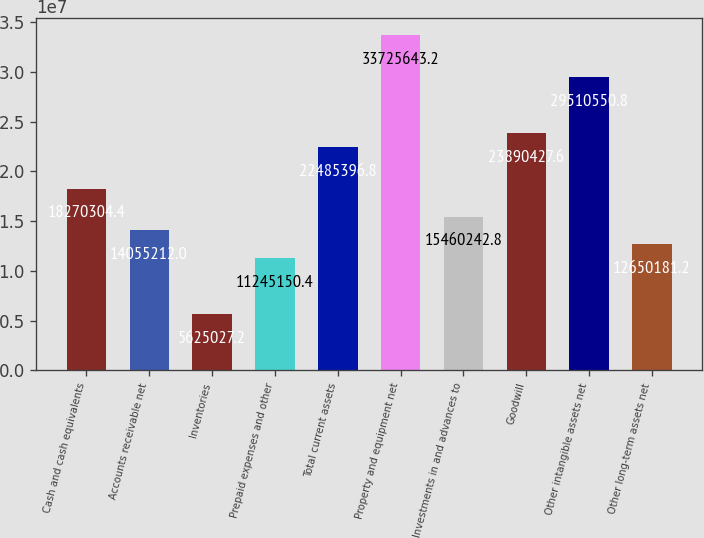<chart> <loc_0><loc_0><loc_500><loc_500><bar_chart><fcel>Cash and cash equivalents<fcel>Accounts receivable net<fcel>Inventories<fcel>Prepaid expenses and other<fcel>Total current assets<fcel>Property and equipment net<fcel>Investments in and advances to<fcel>Goodwill<fcel>Other intangible assets net<fcel>Other long-term assets net<nl><fcel>1.82703e+07<fcel>1.40552e+07<fcel>5.62503e+06<fcel>1.12452e+07<fcel>2.24854e+07<fcel>3.37256e+07<fcel>1.54602e+07<fcel>2.38904e+07<fcel>2.95106e+07<fcel>1.26502e+07<nl></chart> 